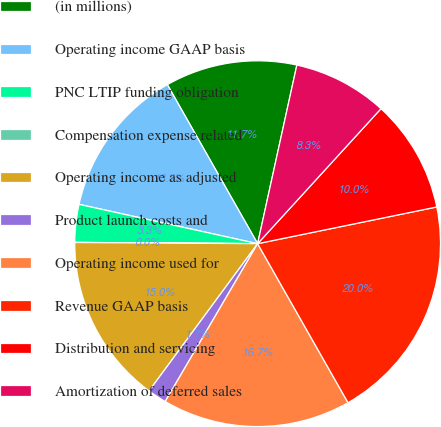Convert chart to OTSL. <chart><loc_0><loc_0><loc_500><loc_500><pie_chart><fcel>(in millions)<fcel>Operating income GAAP basis<fcel>PNC LTIP funding obligation<fcel>Compensation expense related<fcel>Operating income as adjusted<fcel>Product launch costs and<fcel>Operating income used for<fcel>Revenue GAAP basis<fcel>Distribution and servicing<fcel>Amortization of deferred sales<nl><fcel>11.66%<fcel>13.33%<fcel>3.34%<fcel>0.01%<fcel>14.99%<fcel>1.68%<fcel>16.66%<fcel>19.99%<fcel>10.0%<fcel>8.34%<nl></chart> 